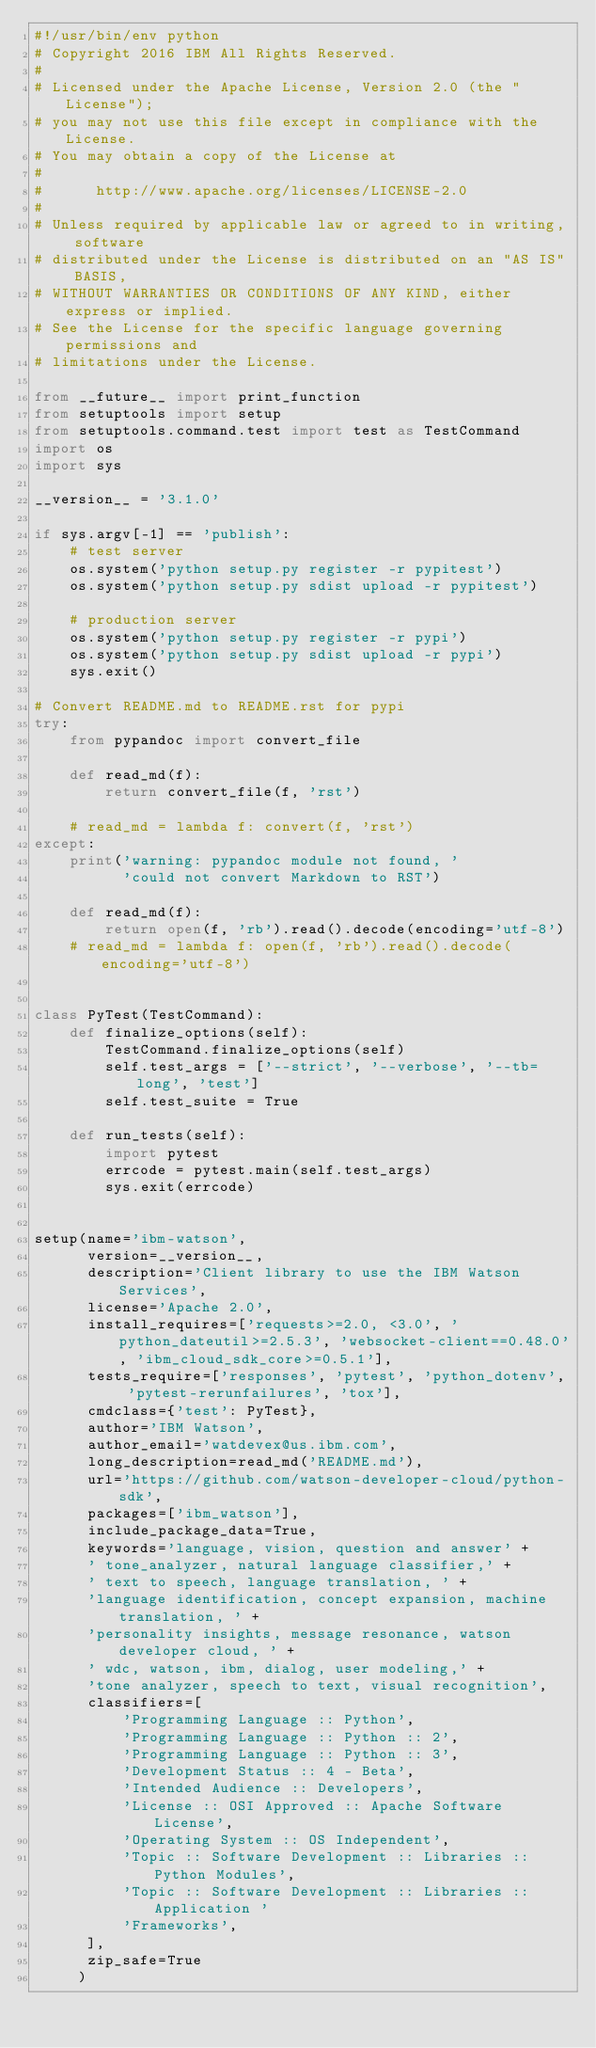Convert code to text. <code><loc_0><loc_0><loc_500><loc_500><_Python_>#!/usr/bin/env python
# Copyright 2016 IBM All Rights Reserved.
#
# Licensed under the Apache License, Version 2.0 (the "License");
# you may not use this file except in compliance with the License.
# You may obtain a copy of the License at
#
#      http://www.apache.org/licenses/LICENSE-2.0
#
# Unless required by applicable law or agreed to in writing, software
# distributed under the License is distributed on an "AS IS" BASIS,
# WITHOUT WARRANTIES OR CONDITIONS OF ANY KIND, either express or implied.
# See the License for the specific language governing permissions and
# limitations under the License.

from __future__ import print_function
from setuptools import setup
from setuptools.command.test import test as TestCommand
import os
import sys

__version__ = '3.1.0'

if sys.argv[-1] == 'publish':
    # test server
    os.system('python setup.py register -r pypitest')
    os.system('python setup.py sdist upload -r pypitest')

    # production server
    os.system('python setup.py register -r pypi')
    os.system('python setup.py sdist upload -r pypi')
    sys.exit()

# Convert README.md to README.rst for pypi
try:
    from pypandoc import convert_file

    def read_md(f):
        return convert_file(f, 'rst')

    # read_md = lambda f: convert(f, 'rst')
except:
    print('warning: pypandoc module not found, '
          'could not convert Markdown to RST')

    def read_md(f):
        return open(f, 'rb').read().decode(encoding='utf-8')
    # read_md = lambda f: open(f, 'rb').read().decode(encoding='utf-8')


class PyTest(TestCommand):
    def finalize_options(self):
        TestCommand.finalize_options(self)
        self.test_args = ['--strict', '--verbose', '--tb=long', 'test']
        self.test_suite = True

    def run_tests(self):
        import pytest
        errcode = pytest.main(self.test_args)
        sys.exit(errcode)


setup(name='ibm-watson',
      version=__version__,
      description='Client library to use the IBM Watson Services',
      license='Apache 2.0',
      install_requires=['requests>=2.0, <3.0', 'python_dateutil>=2.5.3', 'websocket-client==0.48.0', 'ibm_cloud_sdk_core>=0.5.1'],
      tests_require=['responses', 'pytest', 'python_dotenv', 'pytest-rerunfailures', 'tox'],
      cmdclass={'test': PyTest},
      author='IBM Watson',
      author_email='watdevex@us.ibm.com',
      long_description=read_md('README.md'),
      url='https://github.com/watson-developer-cloud/python-sdk',
      packages=['ibm_watson'],
      include_package_data=True,
      keywords='language, vision, question and answer' +
      ' tone_analyzer, natural language classifier,' +
      ' text to speech, language translation, ' +
      'language identification, concept expansion, machine translation, ' +
      'personality insights, message resonance, watson developer cloud, ' +
      ' wdc, watson, ibm, dialog, user modeling,' +
      'tone analyzer, speech to text, visual recognition',
      classifiers=[
          'Programming Language :: Python',
          'Programming Language :: Python :: 2',
          'Programming Language :: Python :: 3',
          'Development Status :: 4 - Beta',
          'Intended Audience :: Developers',
          'License :: OSI Approved :: Apache Software License',
          'Operating System :: OS Independent',
          'Topic :: Software Development :: Libraries :: Python Modules',
          'Topic :: Software Development :: Libraries :: Application '
          'Frameworks',
      ],
      zip_safe=True
     )
</code> 